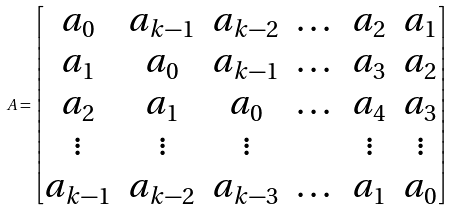<formula> <loc_0><loc_0><loc_500><loc_500>A = \left [ \begin{matrix} a _ { 0 } & a _ { k - 1 } & a _ { k - 2 } & \dots & a _ { 2 } & a _ { 1 } \\ a _ { 1 } & a _ { 0 } & a _ { k - 1 } & \dots & a _ { 3 } & a _ { 2 } \\ a _ { 2 } & a _ { 1 } & a _ { 0 } & \dots & a _ { 4 } & a _ { 3 } \\ \vdots & \vdots & \vdots & & \vdots & \vdots \\ a _ { k - 1 } & a _ { k - 2 } & a _ { k - 3 } & \dots & a _ { 1 } & a _ { 0 } \end{matrix} \right ]</formula> 